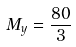Convert formula to latex. <formula><loc_0><loc_0><loc_500><loc_500>M _ { y } = \frac { 8 0 } { 3 }</formula> 